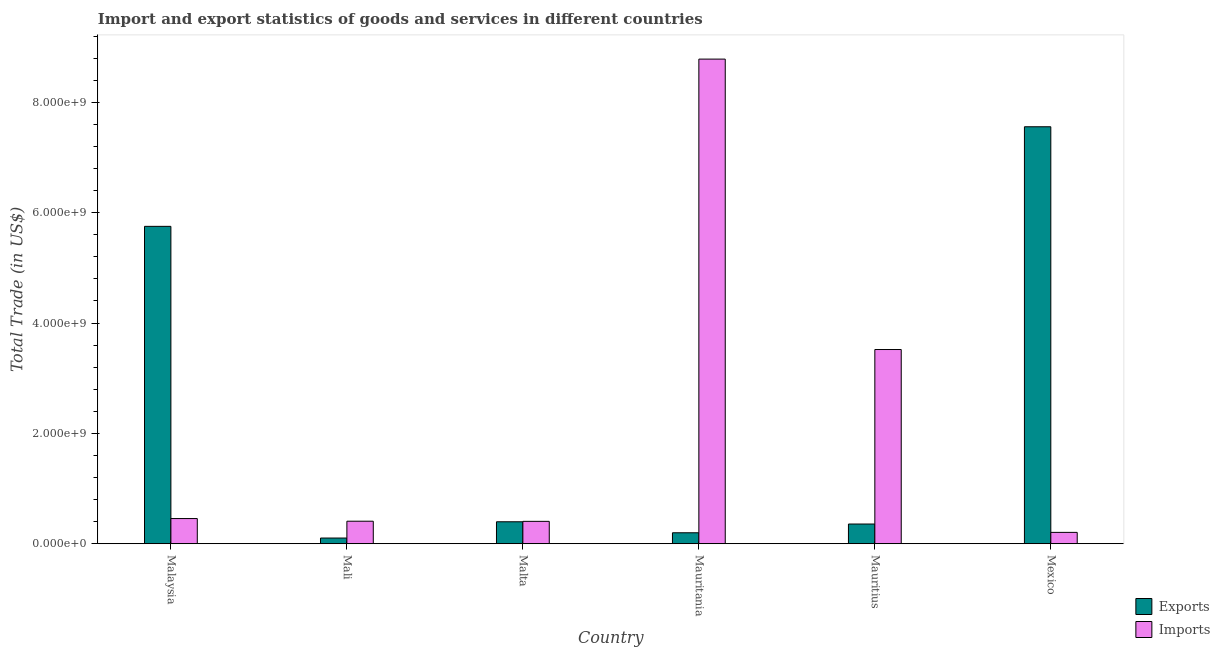How many groups of bars are there?
Offer a terse response. 6. Are the number of bars per tick equal to the number of legend labels?
Give a very brief answer. Yes. How many bars are there on the 6th tick from the right?
Provide a succinct answer. 2. What is the label of the 1st group of bars from the left?
Offer a very short reply. Malaysia. In how many cases, is the number of bars for a given country not equal to the number of legend labels?
Keep it short and to the point. 0. What is the export of goods and services in Mauritius?
Your answer should be very brief. 3.57e+08. Across all countries, what is the maximum imports of goods and services?
Give a very brief answer. 8.78e+09. Across all countries, what is the minimum imports of goods and services?
Your response must be concise. 2.06e+08. In which country was the export of goods and services minimum?
Keep it short and to the point. Mali. What is the total imports of goods and services in the graph?
Your answer should be compact. 1.38e+1. What is the difference between the imports of goods and services in Malta and that in Mauritania?
Offer a very short reply. -8.38e+09. What is the difference between the export of goods and services in Mauritania and the imports of goods and services in Mali?
Your response must be concise. -2.10e+08. What is the average export of goods and services per country?
Your answer should be compact. 2.39e+09. What is the difference between the imports of goods and services and export of goods and services in Malta?
Your response must be concise. 7.76e+06. In how many countries, is the imports of goods and services greater than 4400000000 US$?
Give a very brief answer. 1. What is the ratio of the imports of goods and services in Malaysia to that in Mauritania?
Offer a terse response. 0.05. Is the difference between the export of goods and services in Malta and Mauritius greater than the difference between the imports of goods and services in Malta and Mauritius?
Keep it short and to the point. Yes. What is the difference between the highest and the second highest export of goods and services?
Offer a terse response. 1.81e+09. What is the difference between the highest and the lowest export of goods and services?
Your response must be concise. 7.45e+09. Is the sum of the export of goods and services in Mauritania and Mauritius greater than the maximum imports of goods and services across all countries?
Offer a terse response. No. What does the 2nd bar from the left in Mexico represents?
Provide a short and direct response. Imports. What does the 1st bar from the right in Mexico represents?
Offer a terse response. Imports. How many countries are there in the graph?
Your response must be concise. 6. What is the difference between two consecutive major ticks on the Y-axis?
Make the answer very short. 2.00e+09. Are the values on the major ticks of Y-axis written in scientific E-notation?
Provide a short and direct response. Yes. How many legend labels are there?
Keep it short and to the point. 2. What is the title of the graph?
Ensure brevity in your answer.  Import and export statistics of goods and services in different countries. What is the label or title of the X-axis?
Offer a very short reply. Country. What is the label or title of the Y-axis?
Your answer should be compact. Total Trade (in US$). What is the Total Trade (in US$) in Exports in Malaysia?
Your response must be concise. 5.75e+09. What is the Total Trade (in US$) in Imports in Malaysia?
Keep it short and to the point. 4.57e+08. What is the Total Trade (in US$) of Exports in Mali?
Make the answer very short. 1.03e+08. What is the Total Trade (in US$) in Imports in Mali?
Your response must be concise. 4.08e+08. What is the Total Trade (in US$) of Exports in Malta?
Make the answer very short. 3.98e+08. What is the Total Trade (in US$) of Imports in Malta?
Ensure brevity in your answer.  4.06e+08. What is the Total Trade (in US$) in Exports in Mauritania?
Your response must be concise. 1.99e+08. What is the Total Trade (in US$) in Imports in Mauritania?
Your response must be concise. 8.78e+09. What is the Total Trade (in US$) of Exports in Mauritius?
Your response must be concise. 3.57e+08. What is the Total Trade (in US$) in Imports in Mauritius?
Offer a terse response. 3.52e+09. What is the Total Trade (in US$) in Exports in Mexico?
Provide a succinct answer. 7.56e+09. What is the Total Trade (in US$) of Imports in Mexico?
Your answer should be compact. 2.06e+08. Across all countries, what is the maximum Total Trade (in US$) of Exports?
Ensure brevity in your answer.  7.56e+09. Across all countries, what is the maximum Total Trade (in US$) in Imports?
Provide a succinct answer. 8.78e+09. Across all countries, what is the minimum Total Trade (in US$) of Exports?
Offer a very short reply. 1.03e+08. Across all countries, what is the minimum Total Trade (in US$) in Imports?
Your answer should be very brief. 2.06e+08. What is the total Total Trade (in US$) in Exports in the graph?
Keep it short and to the point. 1.44e+1. What is the total Total Trade (in US$) in Imports in the graph?
Your answer should be very brief. 1.38e+1. What is the difference between the Total Trade (in US$) in Exports in Malaysia and that in Mali?
Your answer should be very brief. 5.65e+09. What is the difference between the Total Trade (in US$) of Imports in Malaysia and that in Mali?
Provide a short and direct response. 4.81e+07. What is the difference between the Total Trade (in US$) in Exports in Malaysia and that in Malta?
Make the answer very short. 5.35e+09. What is the difference between the Total Trade (in US$) of Imports in Malaysia and that in Malta?
Give a very brief answer. 5.07e+07. What is the difference between the Total Trade (in US$) in Exports in Malaysia and that in Mauritania?
Provide a succinct answer. 5.55e+09. What is the difference between the Total Trade (in US$) in Imports in Malaysia and that in Mauritania?
Provide a short and direct response. -8.33e+09. What is the difference between the Total Trade (in US$) in Exports in Malaysia and that in Mauritius?
Offer a terse response. 5.40e+09. What is the difference between the Total Trade (in US$) in Imports in Malaysia and that in Mauritius?
Give a very brief answer. -3.06e+09. What is the difference between the Total Trade (in US$) of Exports in Malaysia and that in Mexico?
Your answer should be very brief. -1.81e+09. What is the difference between the Total Trade (in US$) of Imports in Malaysia and that in Mexico?
Ensure brevity in your answer.  2.51e+08. What is the difference between the Total Trade (in US$) of Exports in Mali and that in Malta?
Your response must be concise. -2.95e+08. What is the difference between the Total Trade (in US$) of Imports in Mali and that in Malta?
Make the answer very short. 2.59e+06. What is the difference between the Total Trade (in US$) of Exports in Mali and that in Mauritania?
Offer a very short reply. -9.56e+07. What is the difference between the Total Trade (in US$) in Imports in Mali and that in Mauritania?
Offer a terse response. -8.38e+09. What is the difference between the Total Trade (in US$) of Exports in Mali and that in Mauritius?
Ensure brevity in your answer.  -2.54e+08. What is the difference between the Total Trade (in US$) of Imports in Mali and that in Mauritius?
Your response must be concise. -3.11e+09. What is the difference between the Total Trade (in US$) in Exports in Mali and that in Mexico?
Your response must be concise. -7.45e+09. What is the difference between the Total Trade (in US$) in Imports in Mali and that in Mexico?
Offer a very short reply. 2.03e+08. What is the difference between the Total Trade (in US$) in Exports in Malta and that in Mauritania?
Your response must be concise. 1.99e+08. What is the difference between the Total Trade (in US$) of Imports in Malta and that in Mauritania?
Offer a terse response. -8.38e+09. What is the difference between the Total Trade (in US$) of Exports in Malta and that in Mauritius?
Provide a succinct answer. 4.07e+07. What is the difference between the Total Trade (in US$) of Imports in Malta and that in Mauritius?
Your response must be concise. -3.11e+09. What is the difference between the Total Trade (in US$) of Exports in Malta and that in Mexico?
Provide a succinct answer. -7.16e+09. What is the difference between the Total Trade (in US$) in Imports in Malta and that in Mexico?
Your response must be concise. 2.00e+08. What is the difference between the Total Trade (in US$) of Exports in Mauritania and that in Mauritius?
Offer a terse response. -1.58e+08. What is the difference between the Total Trade (in US$) of Imports in Mauritania and that in Mauritius?
Your response must be concise. 5.26e+09. What is the difference between the Total Trade (in US$) in Exports in Mauritania and that in Mexico?
Your answer should be very brief. -7.36e+09. What is the difference between the Total Trade (in US$) in Imports in Mauritania and that in Mexico?
Ensure brevity in your answer.  8.58e+09. What is the difference between the Total Trade (in US$) of Exports in Mauritius and that in Mexico?
Provide a succinct answer. -7.20e+09. What is the difference between the Total Trade (in US$) of Imports in Mauritius and that in Mexico?
Give a very brief answer. 3.31e+09. What is the difference between the Total Trade (in US$) in Exports in Malaysia and the Total Trade (in US$) in Imports in Mali?
Provide a short and direct response. 5.34e+09. What is the difference between the Total Trade (in US$) in Exports in Malaysia and the Total Trade (in US$) in Imports in Malta?
Make the answer very short. 5.35e+09. What is the difference between the Total Trade (in US$) of Exports in Malaysia and the Total Trade (in US$) of Imports in Mauritania?
Give a very brief answer. -3.03e+09. What is the difference between the Total Trade (in US$) of Exports in Malaysia and the Total Trade (in US$) of Imports in Mauritius?
Offer a terse response. 2.23e+09. What is the difference between the Total Trade (in US$) of Exports in Malaysia and the Total Trade (in US$) of Imports in Mexico?
Give a very brief answer. 5.55e+09. What is the difference between the Total Trade (in US$) of Exports in Mali and the Total Trade (in US$) of Imports in Malta?
Your response must be concise. -3.03e+08. What is the difference between the Total Trade (in US$) of Exports in Mali and the Total Trade (in US$) of Imports in Mauritania?
Make the answer very short. -8.68e+09. What is the difference between the Total Trade (in US$) of Exports in Mali and the Total Trade (in US$) of Imports in Mauritius?
Your answer should be very brief. -3.42e+09. What is the difference between the Total Trade (in US$) in Exports in Mali and the Total Trade (in US$) in Imports in Mexico?
Ensure brevity in your answer.  -1.03e+08. What is the difference between the Total Trade (in US$) in Exports in Malta and the Total Trade (in US$) in Imports in Mauritania?
Make the answer very short. -8.39e+09. What is the difference between the Total Trade (in US$) of Exports in Malta and the Total Trade (in US$) of Imports in Mauritius?
Make the answer very short. -3.12e+09. What is the difference between the Total Trade (in US$) in Exports in Malta and the Total Trade (in US$) in Imports in Mexico?
Keep it short and to the point. 1.92e+08. What is the difference between the Total Trade (in US$) of Exports in Mauritania and the Total Trade (in US$) of Imports in Mauritius?
Keep it short and to the point. -3.32e+09. What is the difference between the Total Trade (in US$) in Exports in Mauritania and the Total Trade (in US$) in Imports in Mexico?
Offer a terse response. -6.98e+06. What is the difference between the Total Trade (in US$) of Exports in Mauritius and the Total Trade (in US$) of Imports in Mexico?
Provide a succinct answer. 1.51e+08. What is the average Total Trade (in US$) of Exports per country?
Keep it short and to the point. 2.39e+09. What is the average Total Trade (in US$) of Imports per country?
Ensure brevity in your answer.  2.30e+09. What is the difference between the Total Trade (in US$) of Exports and Total Trade (in US$) of Imports in Malaysia?
Offer a very short reply. 5.30e+09. What is the difference between the Total Trade (in US$) in Exports and Total Trade (in US$) in Imports in Mali?
Ensure brevity in your answer.  -3.05e+08. What is the difference between the Total Trade (in US$) of Exports and Total Trade (in US$) of Imports in Malta?
Ensure brevity in your answer.  -7.76e+06. What is the difference between the Total Trade (in US$) of Exports and Total Trade (in US$) of Imports in Mauritania?
Make the answer very short. -8.59e+09. What is the difference between the Total Trade (in US$) in Exports and Total Trade (in US$) in Imports in Mauritius?
Your answer should be compact. -3.16e+09. What is the difference between the Total Trade (in US$) in Exports and Total Trade (in US$) in Imports in Mexico?
Your answer should be compact. 7.35e+09. What is the ratio of the Total Trade (in US$) in Exports in Malaysia to that in Mali?
Your response must be concise. 55.66. What is the ratio of the Total Trade (in US$) of Imports in Malaysia to that in Mali?
Give a very brief answer. 1.12. What is the ratio of the Total Trade (in US$) of Exports in Malaysia to that in Malta?
Offer a very short reply. 14.45. What is the ratio of the Total Trade (in US$) in Imports in Malaysia to that in Malta?
Offer a terse response. 1.12. What is the ratio of the Total Trade (in US$) of Exports in Malaysia to that in Mauritania?
Your answer should be very brief. 28.91. What is the ratio of the Total Trade (in US$) in Imports in Malaysia to that in Mauritania?
Make the answer very short. 0.05. What is the ratio of the Total Trade (in US$) of Exports in Malaysia to that in Mauritius?
Give a very brief answer. 16.1. What is the ratio of the Total Trade (in US$) of Imports in Malaysia to that in Mauritius?
Give a very brief answer. 0.13. What is the ratio of the Total Trade (in US$) of Exports in Malaysia to that in Mexico?
Make the answer very short. 0.76. What is the ratio of the Total Trade (in US$) in Imports in Malaysia to that in Mexico?
Offer a terse response. 2.22. What is the ratio of the Total Trade (in US$) of Exports in Mali to that in Malta?
Your answer should be compact. 0.26. What is the ratio of the Total Trade (in US$) in Imports in Mali to that in Malta?
Provide a short and direct response. 1.01. What is the ratio of the Total Trade (in US$) of Exports in Mali to that in Mauritania?
Offer a terse response. 0.52. What is the ratio of the Total Trade (in US$) of Imports in Mali to that in Mauritania?
Your answer should be compact. 0.05. What is the ratio of the Total Trade (in US$) of Exports in Mali to that in Mauritius?
Your response must be concise. 0.29. What is the ratio of the Total Trade (in US$) of Imports in Mali to that in Mauritius?
Provide a short and direct response. 0.12. What is the ratio of the Total Trade (in US$) in Exports in Mali to that in Mexico?
Give a very brief answer. 0.01. What is the ratio of the Total Trade (in US$) of Imports in Mali to that in Mexico?
Your response must be concise. 1.98. What is the ratio of the Total Trade (in US$) of Exports in Malta to that in Mauritania?
Your answer should be very brief. 2. What is the ratio of the Total Trade (in US$) of Imports in Malta to that in Mauritania?
Your answer should be compact. 0.05. What is the ratio of the Total Trade (in US$) in Exports in Malta to that in Mauritius?
Provide a short and direct response. 1.11. What is the ratio of the Total Trade (in US$) of Imports in Malta to that in Mauritius?
Offer a very short reply. 0.12. What is the ratio of the Total Trade (in US$) in Exports in Malta to that in Mexico?
Offer a very short reply. 0.05. What is the ratio of the Total Trade (in US$) of Imports in Malta to that in Mexico?
Offer a terse response. 1.97. What is the ratio of the Total Trade (in US$) of Exports in Mauritania to that in Mauritius?
Keep it short and to the point. 0.56. What is the ratio of the Total Trade (in US$) of Imports in Mauritania to that in Mauritius?
Your response must be concise. 2.5. What is the ratio of the Total Trade (in US$) of Exports in Mauritania to that in Mexico?
Offer a very short reply. 0.03. What is the ratio of the Total Trade (in US$) of Imports in Mauritania to that in Mexico?
Offer a terse response. 42.65. What is the ratio of the Total Trade (in US$) of Exports in Mauritius to that in Mexico?
Offer a very short reply. 0.05. What is the ratio of the Total Trade (in US$) in Imports in Mauritius to that in Mexico?
Provide a succinct answer. 17.09. What is the difference between the highest and the second highest Total Trade (in US$) in Exports?
Offer a terse response. 1.81e+09. What is the difference between the highest and the second highest Total Trade (in US$) in Imports?
Ensure brevity in your answer.  5.26e+09. What is the difference between the highest and the lowest Total Trade (in US$) of Exports?
Give a very brief answer. 7.45e+09. What is the difference between the highest and the lowest Total Trade (in US$) in Imports?
Keep it short and to the point. 8.58e+09. 